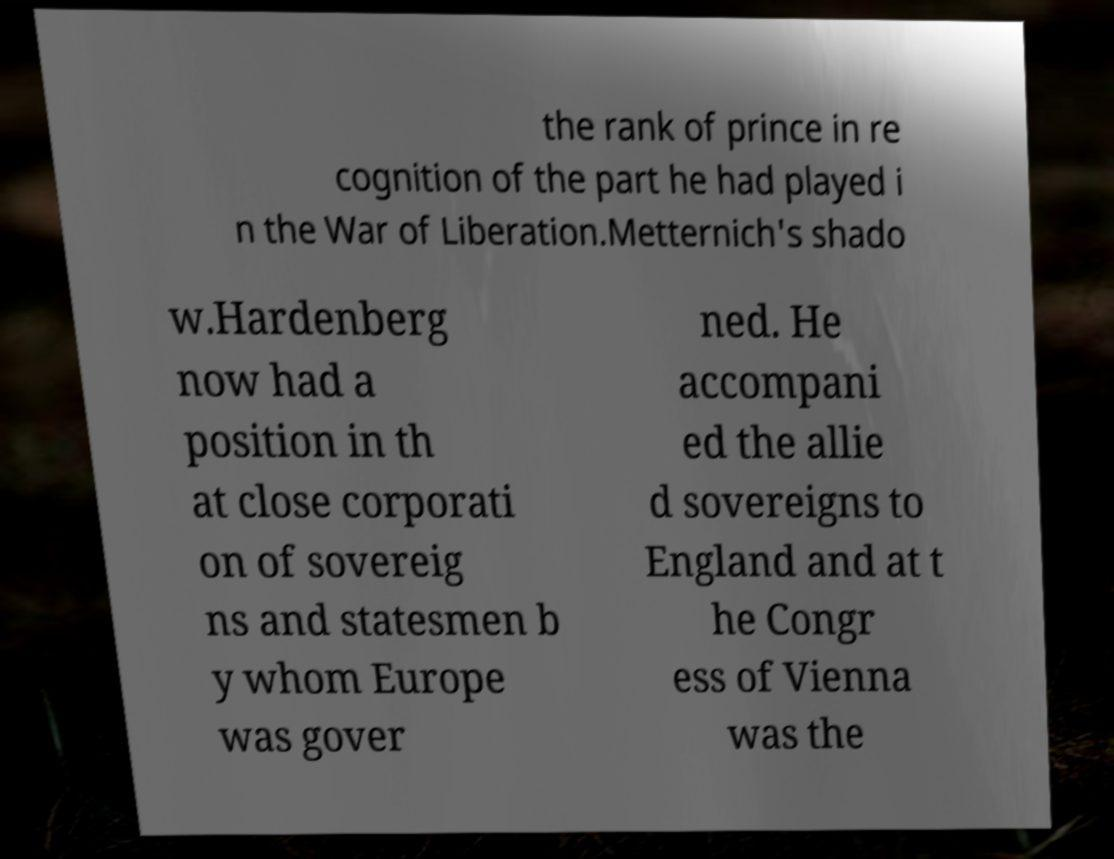What messages or text are displayed in this image? I need them in a readable, typed format. the rank of prince in re cognition of the part he had played i n the War of Liberation.Metternich's shado w.Hardenberg now had a position in th at close corporati on of sovereig ns and statesmen b y whom Europe was gover ned. He accompani ed the allie d sovereigns to England and at t he Congr ess of Vienna was the 